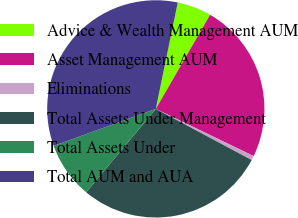<chart> <loc_0><loc_0><loc_500><loc_500><pie_chart><fcel>Advice & Wealth Management AUM<fcel>Asset Management AUM<fcel>Eliminations<fcel>Total Assets Under Management<fcel>Total Assets Under<fcel>Total AUM and AUA<nl><fcel>5.09%<fcel>23.83%<fcel>0.65%<fcel>28.27%<fcel>8.4%<fcel>33.77%<nl></chart> 